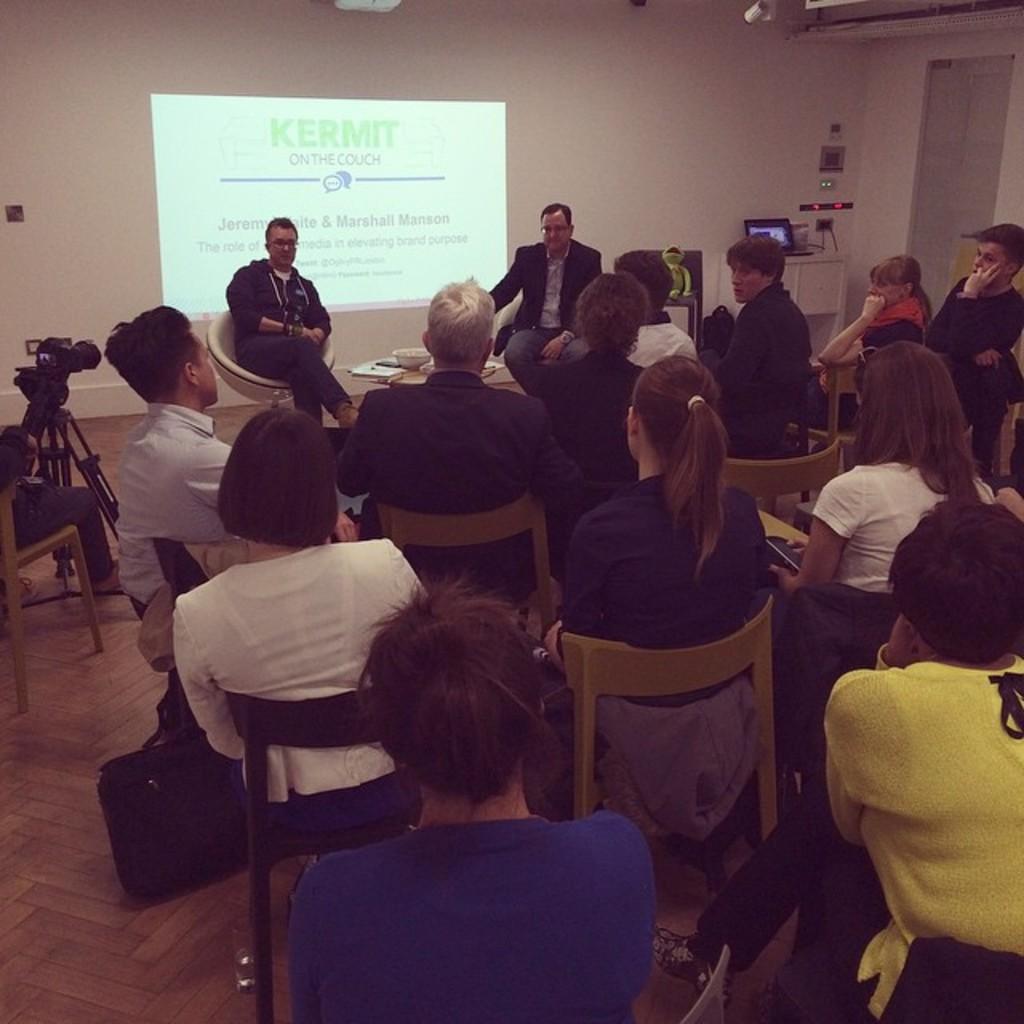Please provide a concise description of this image. In the image there are few people sitting on the chairs. On the left side there is a stand with a camera. In the background on the wall there is a screen. And also there is a table with a monitor and some other things. And also there is a wall with doors. 